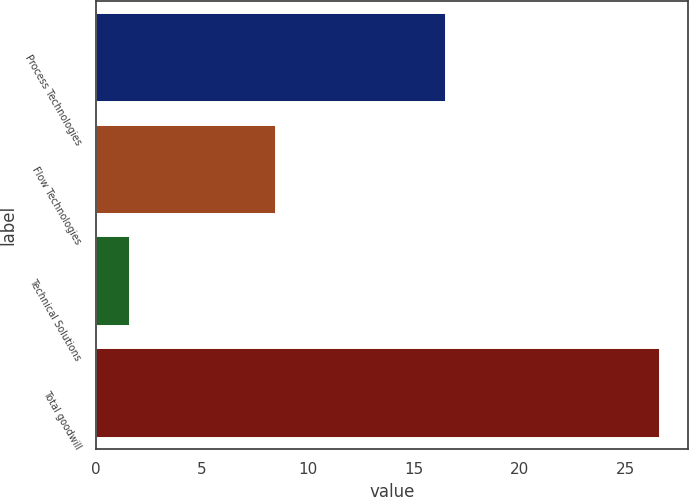Convert chart. <chart><loc_0><loc_0><loc_500><loc_500><bar_chart><fcel>Process Technologies<fcel>Flow Technologies<fcel>Technical Solutions<fcel>Total goodwill<nl><fcel>16.5<fcel>8.5<fcel>1.6<fcel>26.6<nl></chart> 